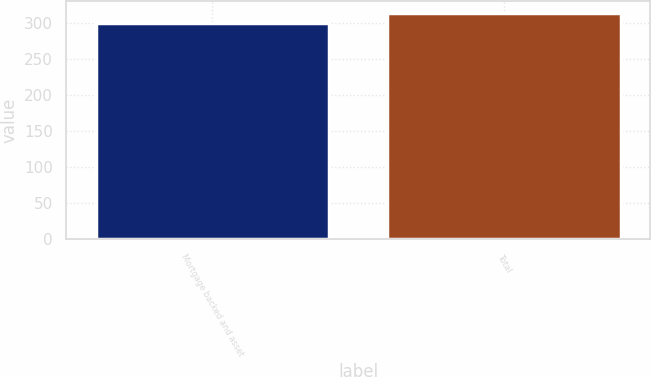<chart> <loc_0><loc_0><loc_500><loc_500><bar_chart><fcel>Mortgage backed and asset<fcel>Total<nl><fcel>300<fcel>315<nl></chart> 